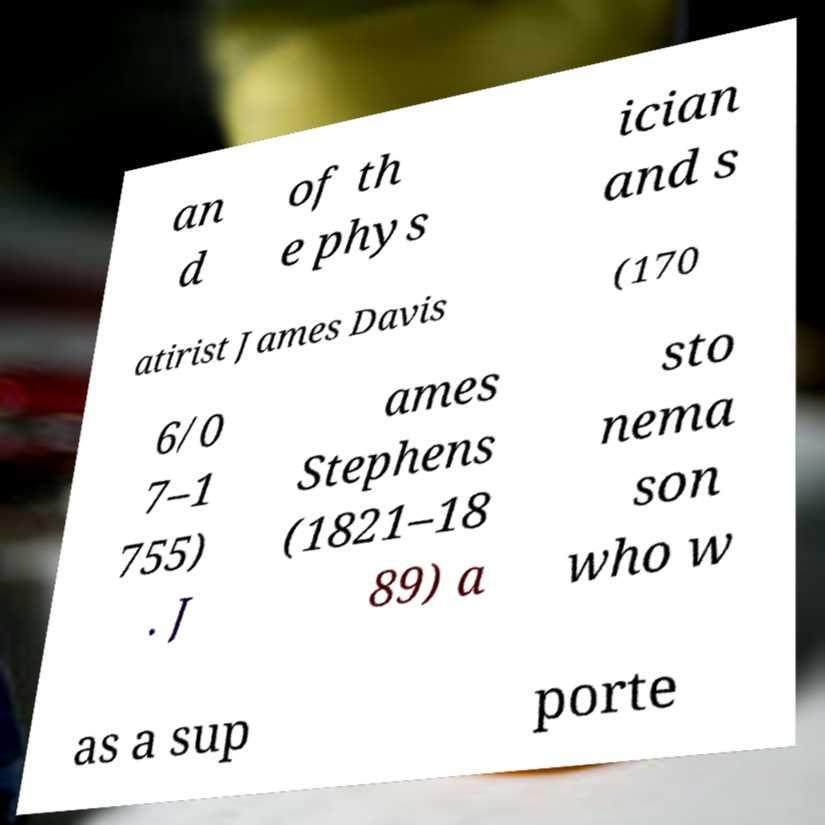Can you read and provide the text displayed in the image?This photo seems to have some interesting text. Can you extract and type it out for me? an d of th e phys ician and s atirist James Davis (170 6/0 7–1 755) . J ames Stephens (1821–18 89) a sto nema son who w as a sup porte 